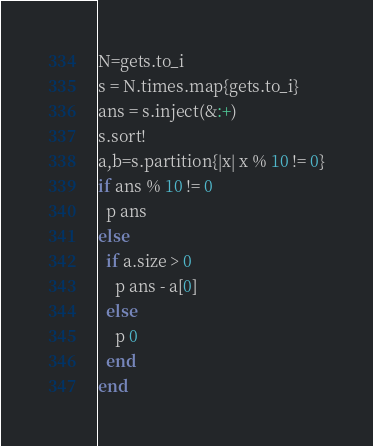Convert code to text. <code><loc_0><loc_0><loc_500><loc_500><_Ruby_>N=gets.to_i
s = N.times.map{gets.to_i}
ans = s.inject(&:+)
s.sort!
a,b=s.partition{|x| x % 10 != 0}
if ans % 10 != 0
  p ans
else
  if a.size > 0
    p ans - a[0]
  else
    p 0
  end
end
</code> 